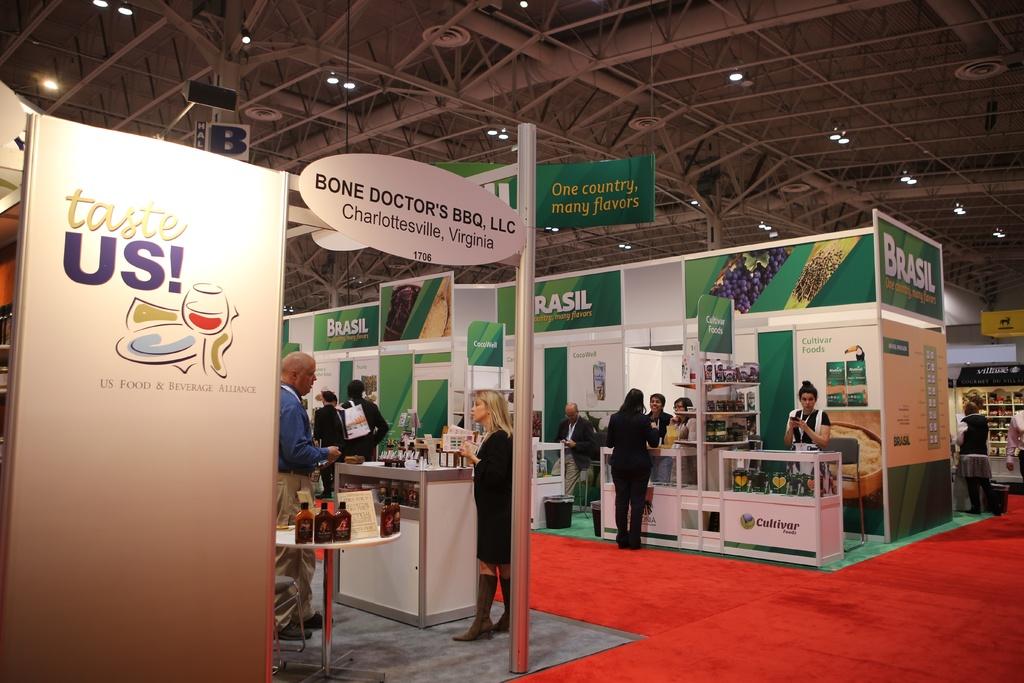Where is bone doctor's bbq, llc located?
Your answer should be very brief. Charlottesville, virginia. What event is this?
Keep it short and to the point. Taste us. 